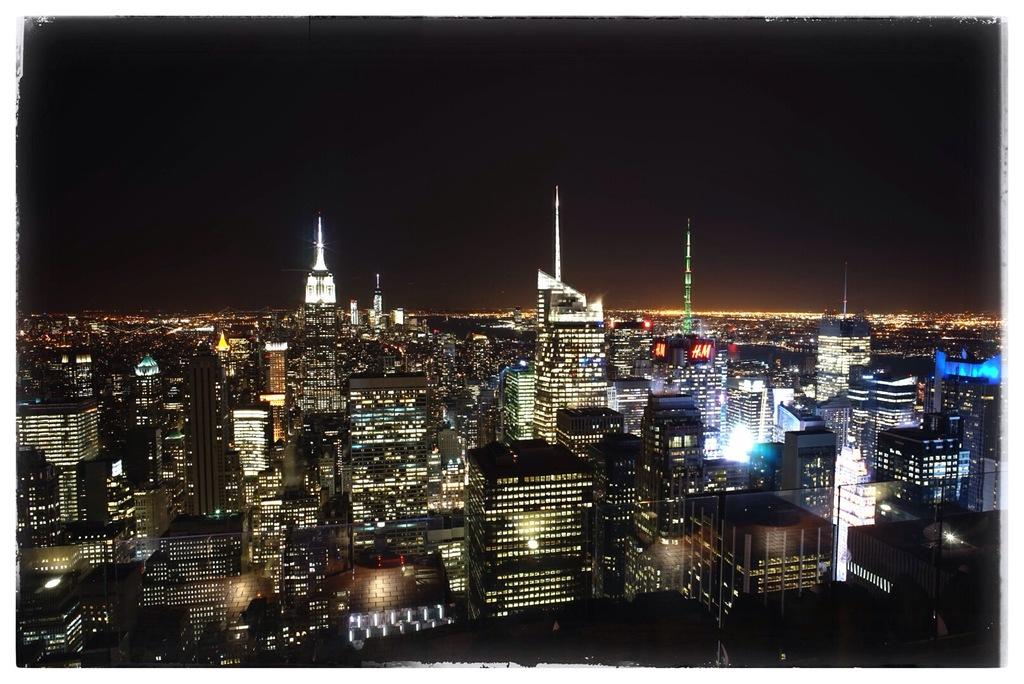What type of structures can be seen in the image? There are buildings in the image. Are there any specific features on the buildings? Yes, there are towers visible on the buildings. What can be seen illuminating the scene in the image? There are lights visible in the image. What is visible in the background of the image? The sky is visible in the background of the image. What type of jewel can be seen hanging from the tree in the image? There is no tree or jewel present in the image; it features buildings, lights, and towers. What type of plot is being developed in the image? The image does not depict a plot or storyline; it is a static scene of buildings, lights, and towers. 